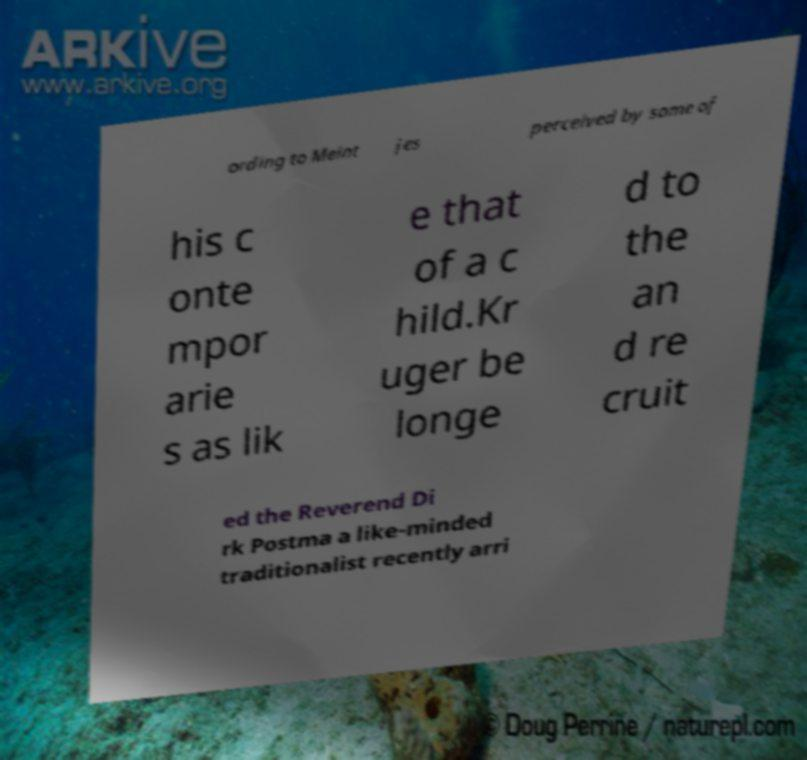Can you read and provide the text displayed in the image?This photo seems to have some interesting text. Can you extract and type it out for me? ording to Meint jes perceived by some of his c onte mpor arie s as lik e that of a c hild.Kr uger be longe d to the an d re cruit ed the Reverend Di rk Postma a like-minded traditionalist recently arri 